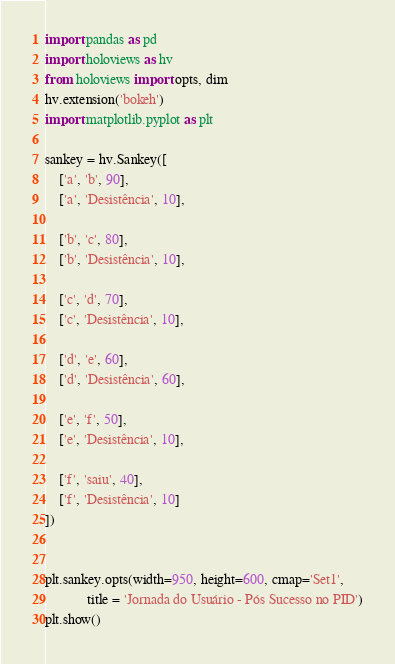<code> <loc_0><loc_0><loc_500><loc_500><_Python_>import pandas as pd
import holoviews as hv
from holoviews import opts, dim
hv.extension('bokeh')
import matplotlib.pyplot as plt

sankey = hv.Sankey([
    ['a', 'b', 90],
    ['a', 'Desistência', 10],

    ['b', 'c', 80],
    ['b', 'Desistência', 10],

    ['c', 'd', 70],
    ['c', 'Desistência', 10],

    ['d', 'e', 60],
    ['d', 'Desistência', 60],

    ['e', 'f', 50],
    ['e', 'Desistência', 10],

    ['f', 'saiu', 40],
    ['f', 'Desistência', 10]
])


plt.sankey.opts(width=950, height=600, cmap='Set1',
            title = 'Jornada do Usuário - Pós Sucesso no PID')
plt.show()
</code> 